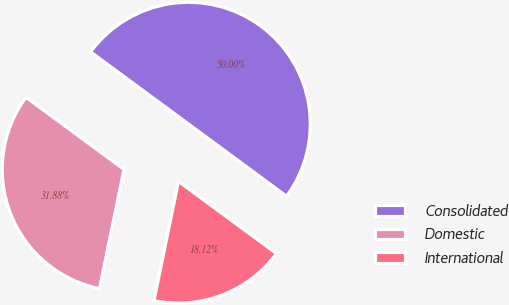Convert chart. <chart><loc_0><loc_0><loc_500><loc_500><pie_chart><fcel>Consolidated<fcel>Domestic<fcel>International<nl><fcel>50.0%<fcel>31.88%<fcel>18.12%<nl></chart> 